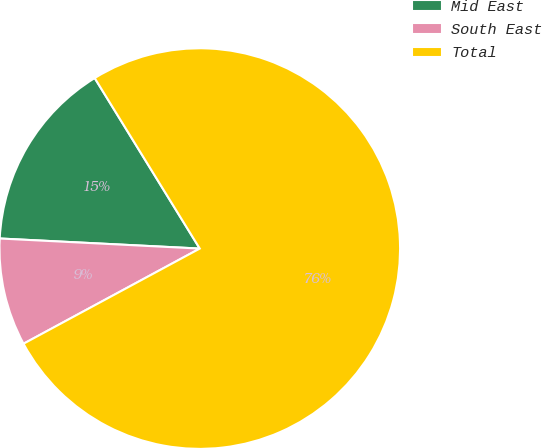Convert chart to OTSL. <chart><loc_0><loc_0><loc_500><loc_500><pie_chart><fcel>Mid East<fcel>South East<fcel>Total<nl><fcel>15.41%<fcel>8.68%<fcel>75.91%<nl></chart> 